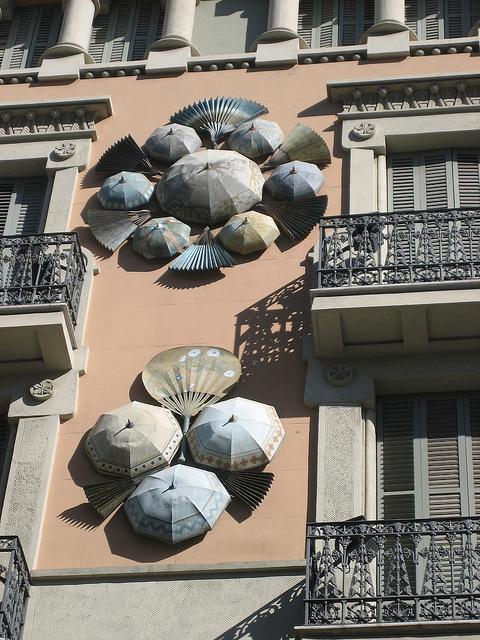How many umbrellas are in the photo?
Give a very brief answer. 6. How many people are wearing white jerseys?
Give a very brief answer. 0. 